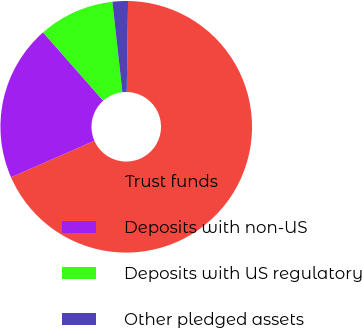Convert chart. <chart><loc_0><loc_0><loc_500><loc_500><pie_chart><fcel>Trust funds<fcel>Deposits with non-US<fcel>Deposits with US regulatory<fcel>Other pledged assets<nl><fcel>68.19%<fcel>20.09%<fcel>9.73%<fcel>1.99%<nl></chart> 